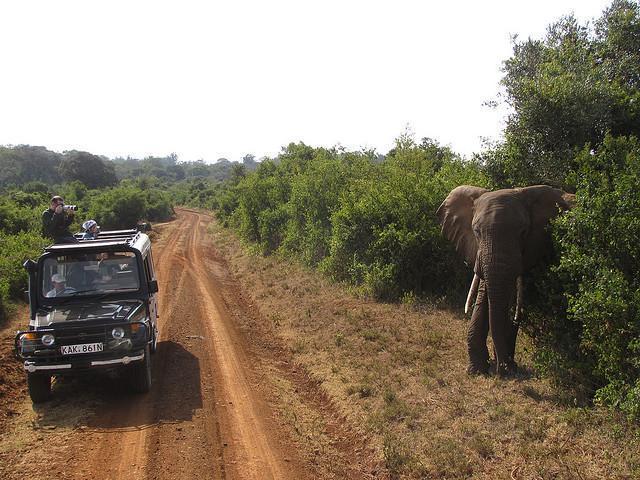How many elephants are there?
Give a very brief answer. 1. How many bears in her arms are brown?
Give a very brief answer. 0. 